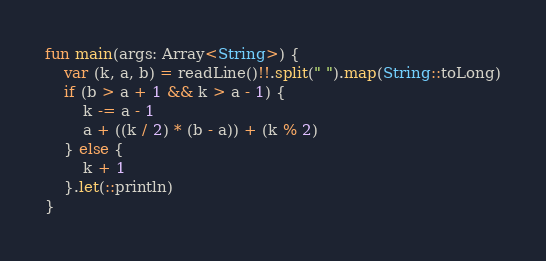<code> <loc_0><loc_0><loc_500><loc_500><_Kotlin_>fun main(args: Array<String>) {
    var (k, a, b) = readLine()!!.split(" ").map(String::toLong)
    if (b > a + 1 && k > a - 1) {
        k -= a - 1
        a + ((k / 2) * (b - a)) + (k % 2)
    } else {
        k + 1
    }.let(::println)
}
</code> 